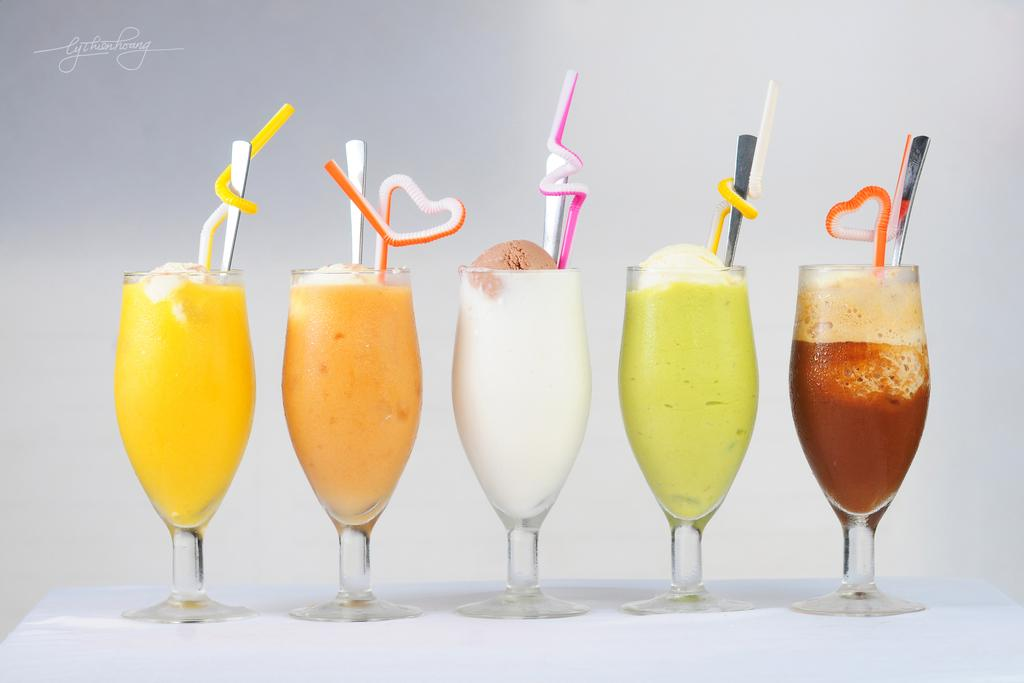What type of food is in the glasses in the image? There are desserts in glasses in the image. What utensils are visible in the image? There are straws and spoons visible in the image. What surface is the desserts and utensils resting on? There is a table at the bottom of the image. What type of fruit is being used as a lamp in the image? There is no fruit or lamp present in the image. 